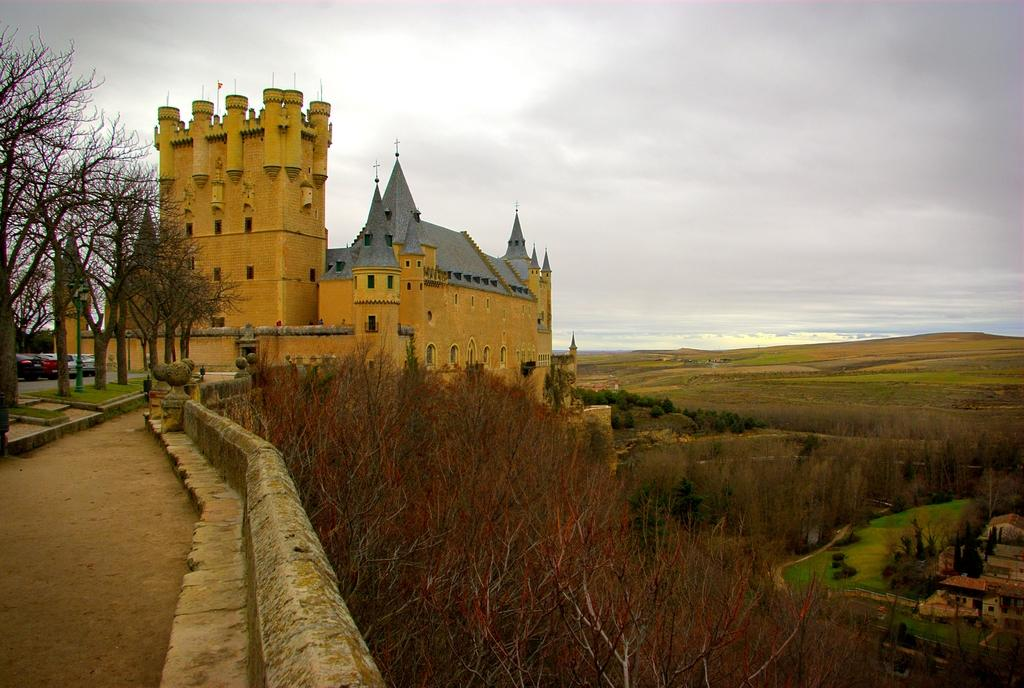What type of vegetation can be seen in the image? There are trees in the image. What is located on the left side of the image? There are cars on the left side of the image. What structure is in the middle of the image? There is a building in the middle of the image. What is visible at the top of the image? The sky is visible at the top of the image. Can you tell me how many baseballs are visible in the image? There are no baseballs present in the image. What type of cream is being used to paint the building in the image? There is no painting or cream visible on the building in the image. 